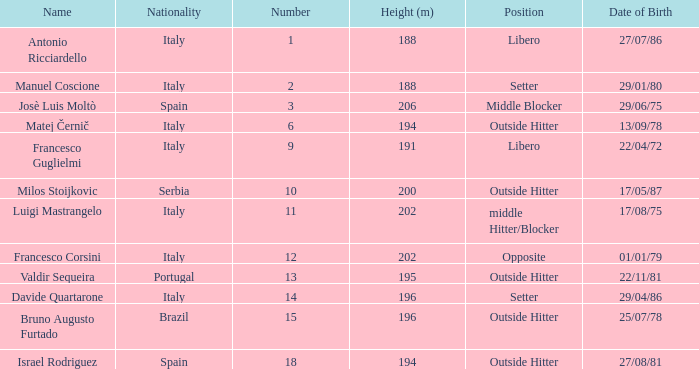Name the date of birth for 27/07/86 Antonio Ricciardello. 